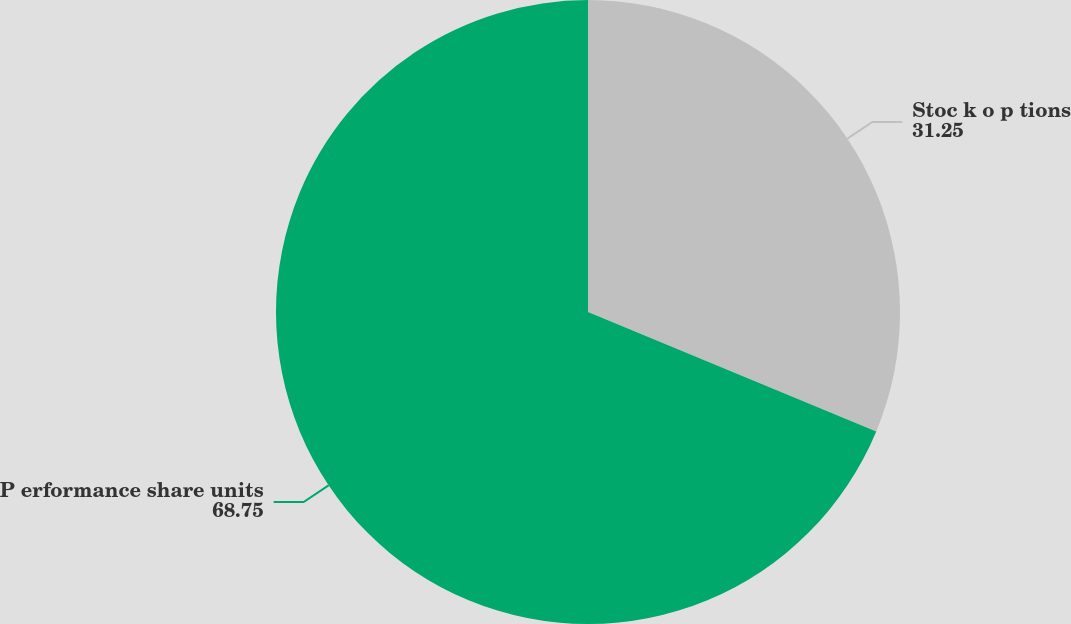Convert chart to OTSL. <chart><loc_0><loc_0><loc_500><loc_500><pie_chart><fcel>Stoc k o p tions<fcel>P erformance share units<nl><fcel>31.25%<fcel>68.75%<nl></chart> 